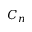Convert formula to latex. <formula><loc_0><loc_0><loc_500><loc_500>C _ { n }</formula> 